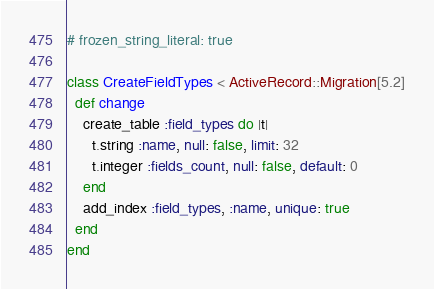Convert code to text. <code><loc_0><loc_0><loc_500><loc_500><_Ruby_># frozen_string_literal: true

class CreateFieldTypes < ActiveRecord::Migration[5.2]
  def change
    create_table :field_types do |t|
      t.string :name, null: false, limit: 32
      t.integer :fields_count, null: false, default: 0
    end
    add_index :field_types, :name, unique: true
  end
end
</code> 